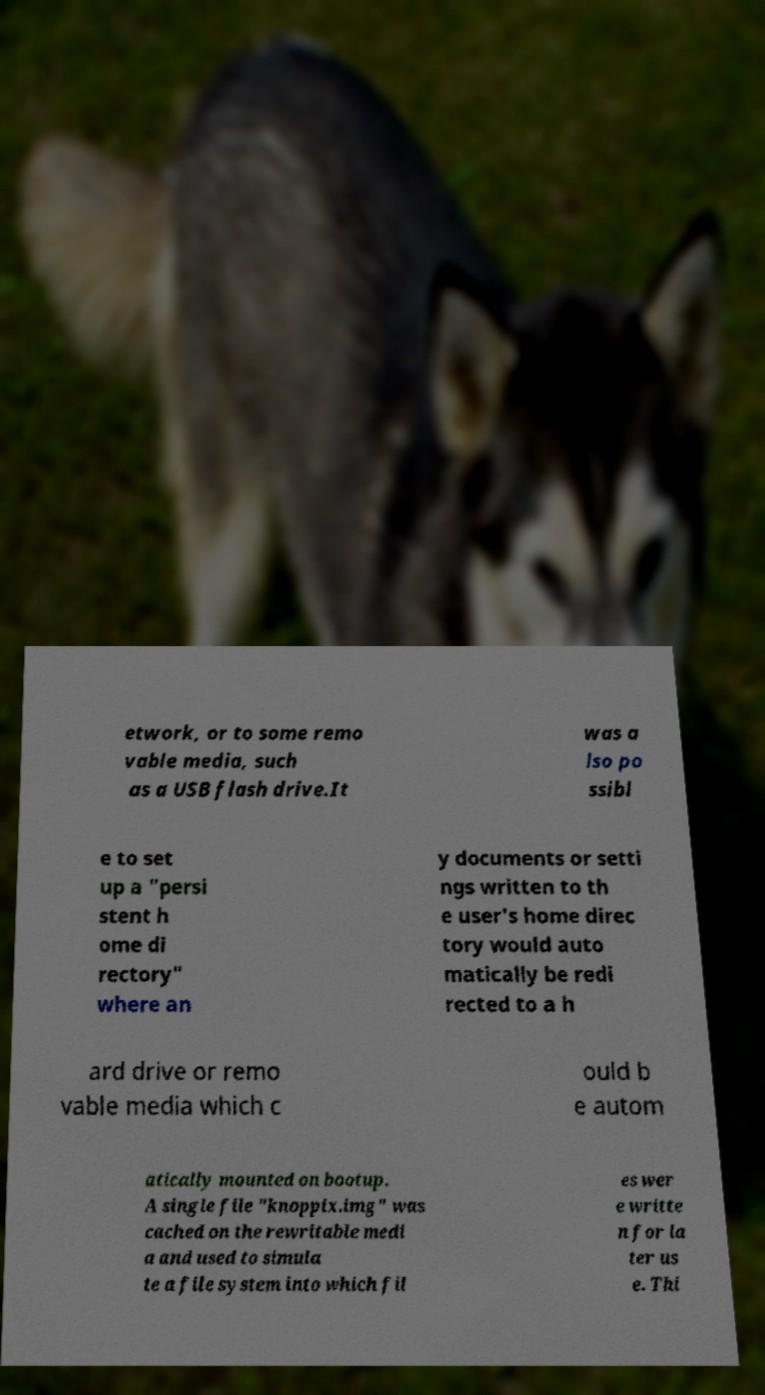Can you read and provide the text displayed in the image?This photo seems to have some interesting text. Can you extract and type it out for me? etwork, or to some remo vable media, such as a USB flash drive.It was a lso po ssibl e to set up a "persi stent h ome di rectory" where an y documents or setti ngs written to th e user's home direc tory would auto matically be redi rected to a h ard drive or remo vable media which c ould b e autom atically mounted on bootup. A single file "knoppix.img" was cached on the rewritable medi a and used to simula te a file system into which fil es wer e writte n for la ter us e. Thi 